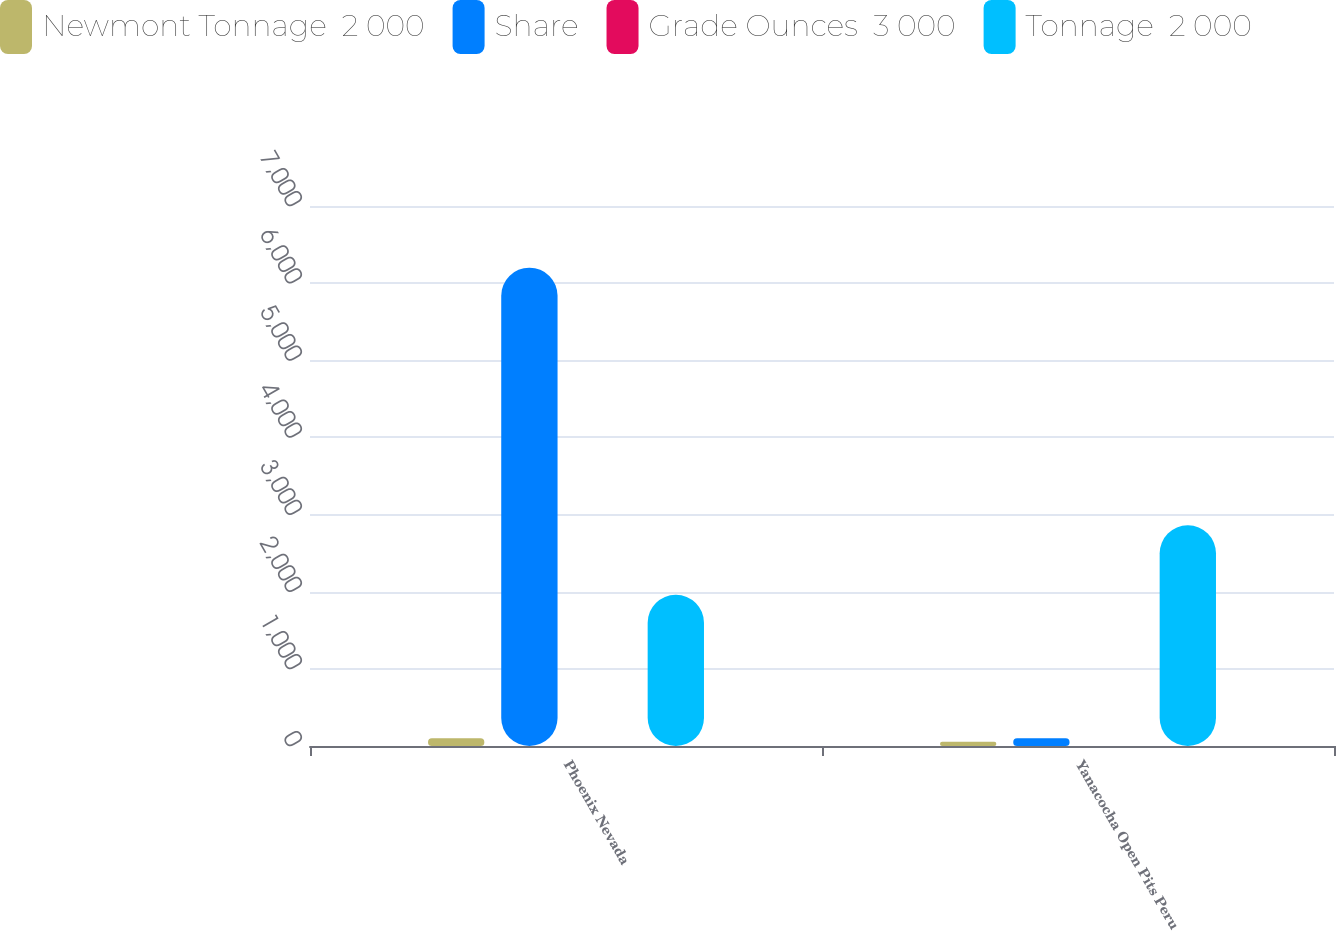Convert chart. <chart><loc_0><loc_0><loc_500><loc_500><stacked_bar_chart><ecel><fcel>Phoenix Nevada<fcel>Yanacocha Open Pits Peru<nl><fcel>Newmont Tonnage  2 000<fcel>100<fcel>54.05<nl><fcel>Share<fcel>6200<fcel>100<nl><fcel>Grade Ounces  3 000<fcel>0.32<fcel>0.23<nl><fcel>Tonnage  2 000<fcel>1960<fcel>2860<nl></chart> 